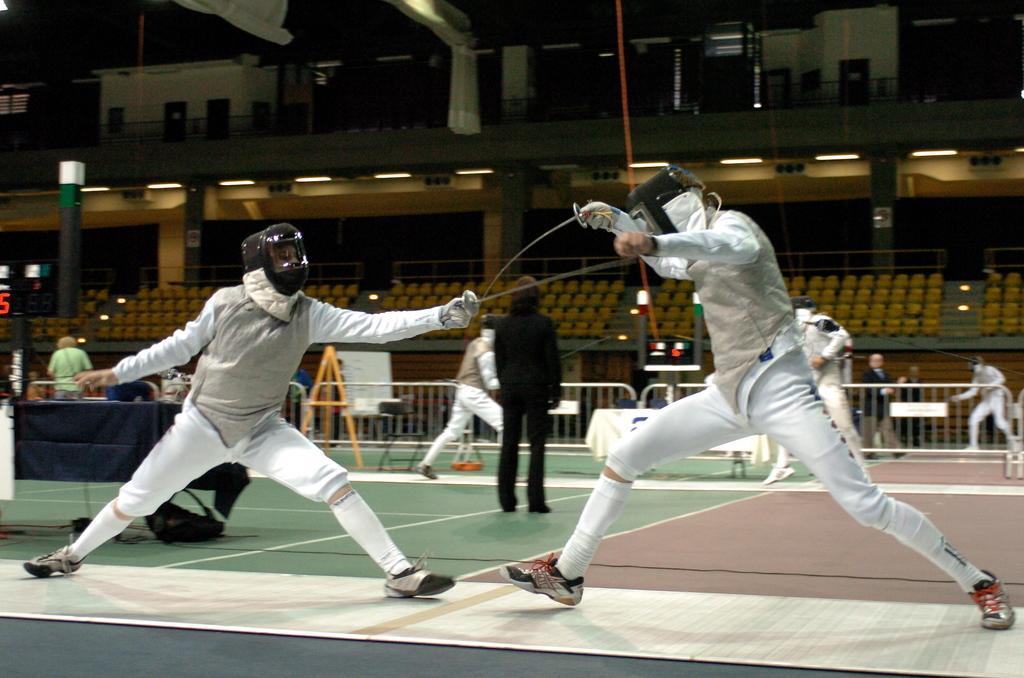Can you describe this image briefly? In this image we can see persons fighting with swords and some persons standing on the floor. In the background we can see railing, pillars, seats and electric lights. 